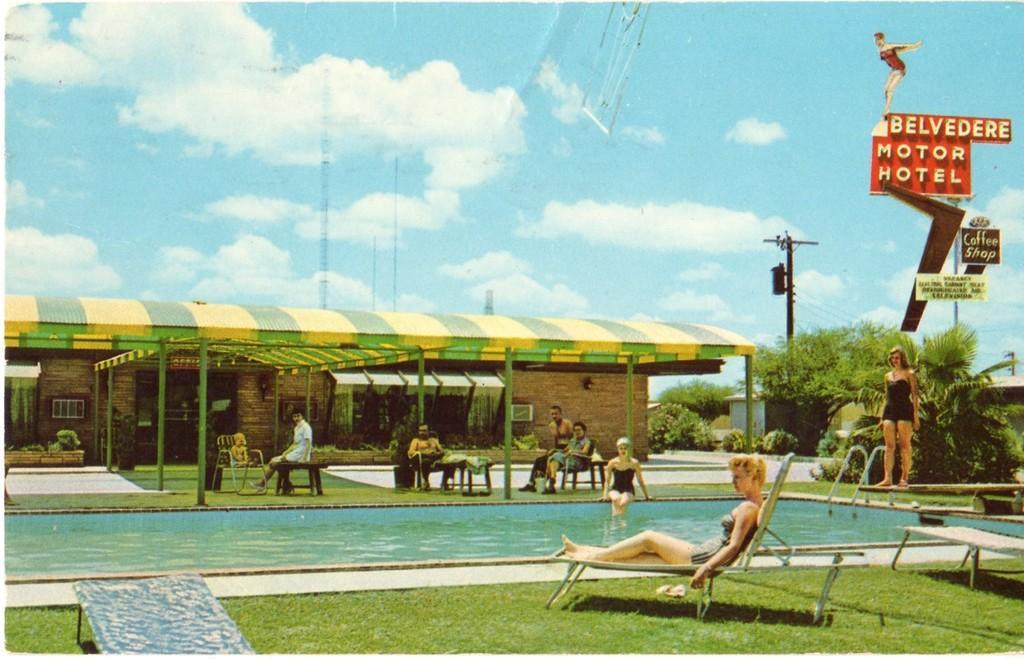Please provide a concise description of this image. Here, we can see a swimming pool, there are some people sitting, there is a shed, we can see some green color plants and trees, at the top there is a sky and we can see some clouds. 